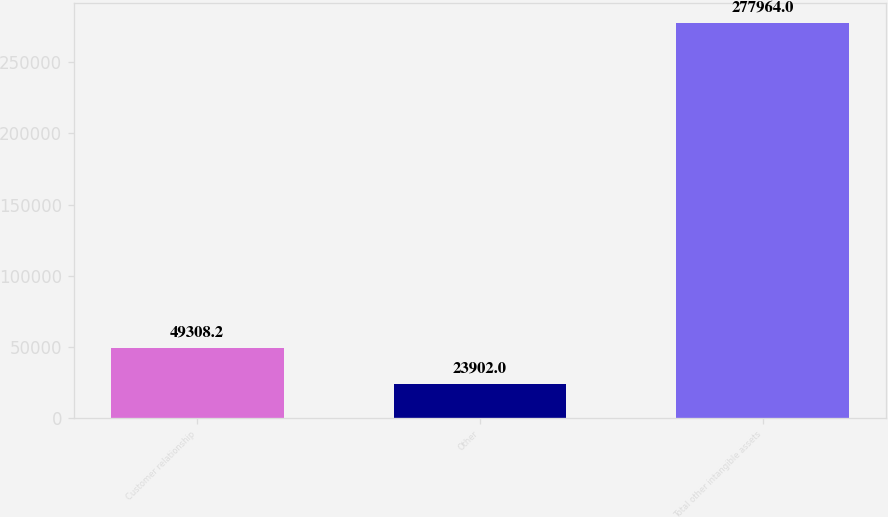<chart> <loc_0><loc_0><loc_500><loc_500><bar_chart><fcel>Customer relationship<fcel>Other<fcel>Total other intangible assets<nl><fcel>49308.2<fcel>23902<fcel>277964<nl></chart> 